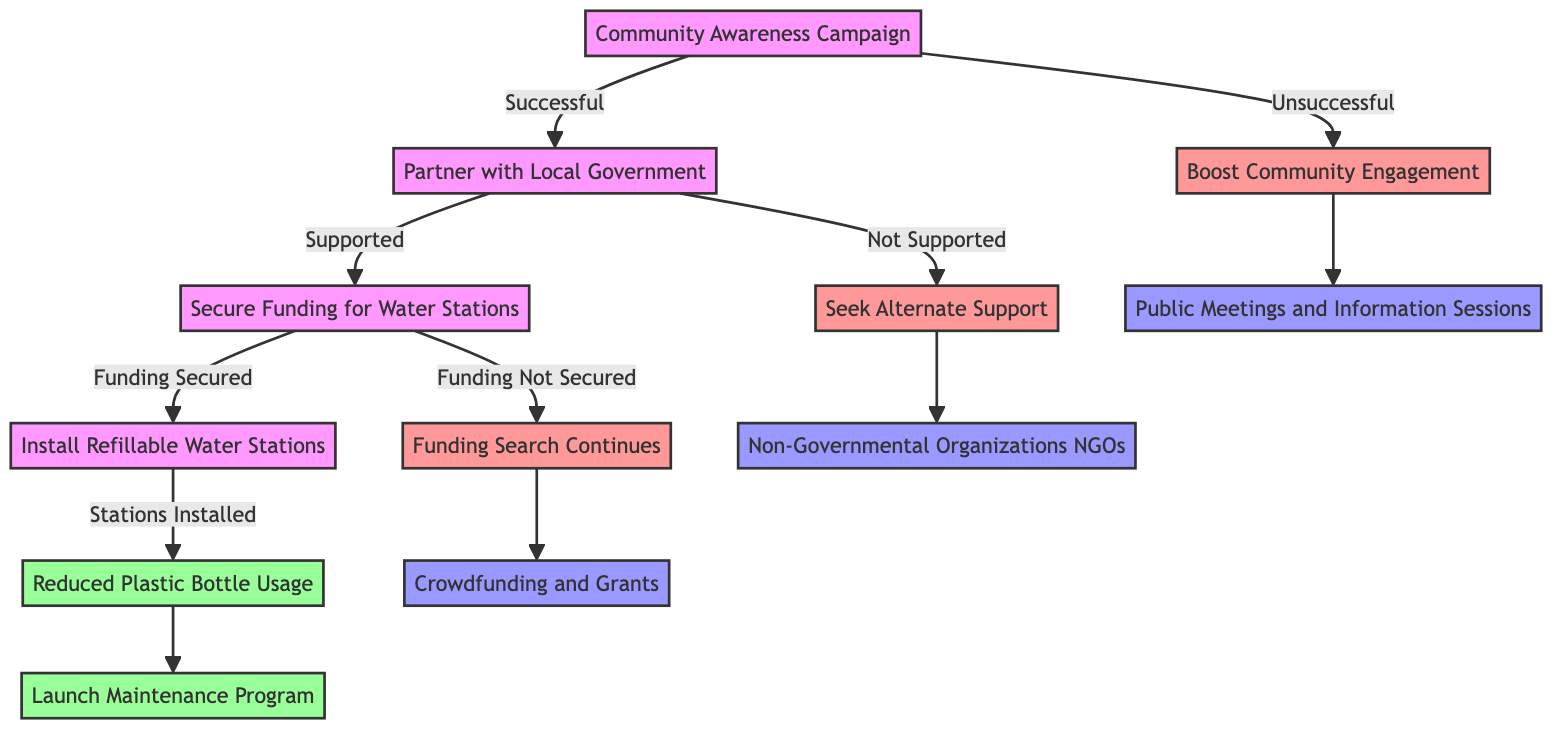What is the starting point of the decision tree? The starting point is the node labeled "Community Awareness Campaign". This is explicitly stated at the top of the diagram and serves as the first action to initiate the subsequent paths.
Answer: Community Awareness Campaign How many outcomes are there after installing refillable water stations? After installing refillable water stations, there is one outcome: "Reduced Plastic Bottle Usage". This can be traced directly from the flow following the node for installing the stations.
Answer: Reduced Plastic Bottle Usage What happens if the funding is not secured? If the funding is not secured, the next step is "Funding Search Continues". This can be determined by following the specific branch we take when moving from "Funding Not Secured".
Answer: Funding Search Continues What is the next step after "Seek Alternate Support"? The next step after "Seek Alternate Support" is to engage with "Non-Governmental Organizations (NGOs)". This is based on the direct connecting edge in the decision tree leading from "Not Supported" to the alternative support pathway.
Answer: Non-Governmental Organizations (NGOs) What action is taken if the awareness campaign is unsuccessful? If the awareness campaign is unsuccessful, the action taken is to "Boost Community Engagement". This connects from the unsuccessful outcome and leads to further community interaction.
Answer: Boost Community Engagement What indicates the successful outcome of the process? The successful outcome of the process is indicated by "Reduced Plastic Bottle Usage". This is the final outcome reached after following the successful path from installing the refillable stations.
Answer: Reduced Plastic Bottle Usage What does the decision tree require after securing funding? After securing funding, the decision tree requires the action: "Install Refillable Water Stations". This is the next designated action after confirming funding support.
Answer: Install Refillable Water Stations How does community engagement start if the awareness campaign fails? Community engagement starts with "Public Meetings and Information Sessions" if the awareness campaign fails. This is the immediate next step following the unsuccessful campaign option.
Answer: Public Meetings and Information Sessions 